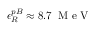<formula> <loc_0><loc_0><loc_500><loc_500>\epsilon _ { R } ^ { p B } \approx 8 . 7 \, M e V</formula> 